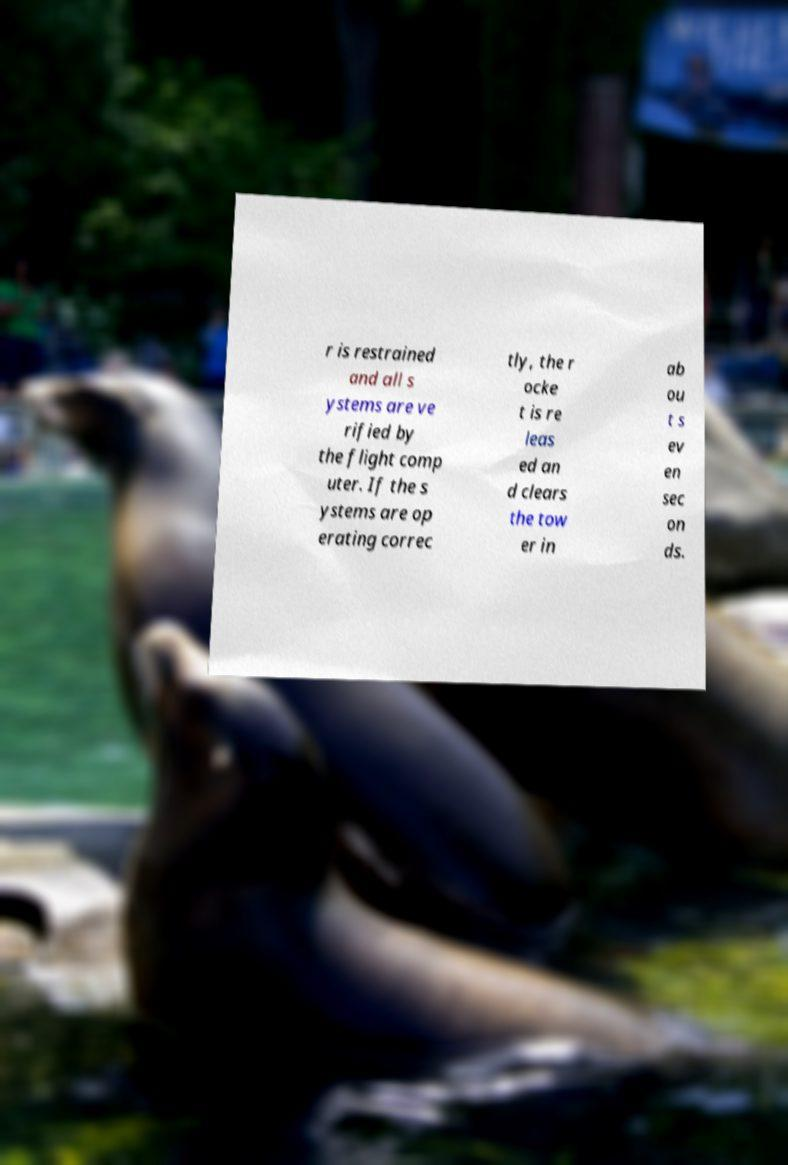Please read and relay the text visible in this image. What does it say? r is restrained and all s ystems are ve rified by the flight comp uter. If the s ystems are op erating correc tly, the r ocke t is re leas ed an d clears the tow er in ab ou t s ev en sec on ds. 